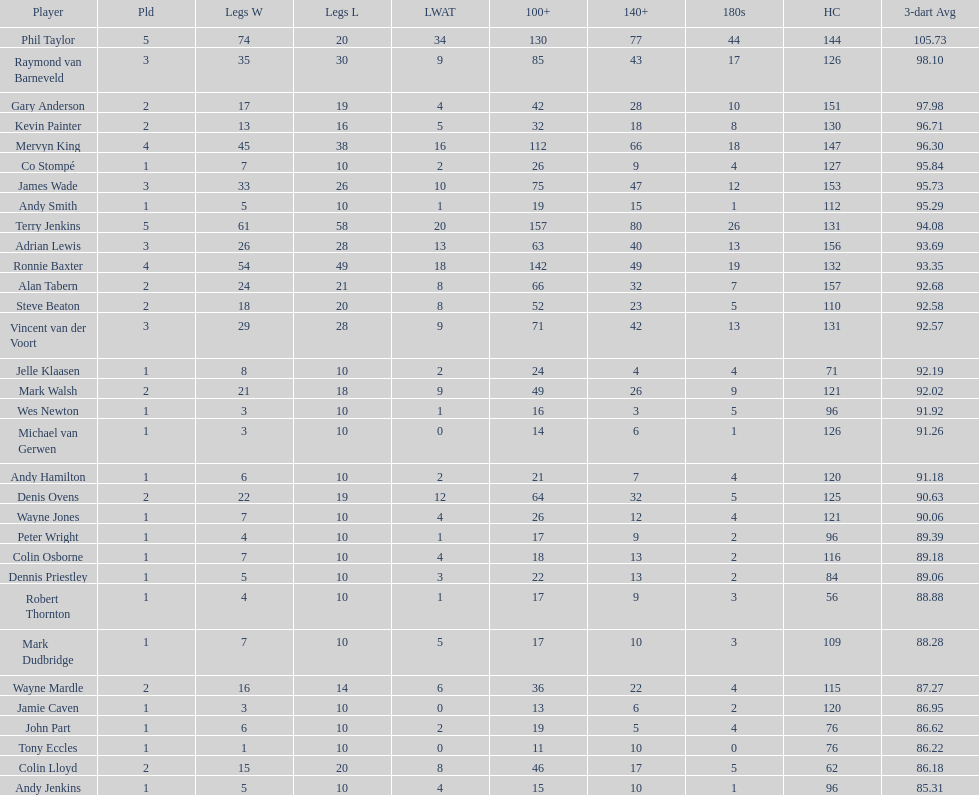How many participants in the 2009 world matchplay secured a minimum of 30 legs? 6. Can you give me this table as a dict? {'header': ['Player', 'Pld', 'Legs W', 'Legs L', 'LWAT', '100+', '140+', '180s', 'HC', '3-dart Avg'], 'rows': [['Phil Taylor', '5', '74', '20', '34', '130', '77', '44', '144', '105.73'], ['Raymond van Barneveld', '3', '35', '30', '9', '85', '43', '17', '126', '98.10'], ['Gary Anderson', '2', '17', '19', '4', '42', '28', '10', '151', '97.98'], ['Kevin Painter', '2', '13', '16', '5', '32', '18', '8', '130', '96.71'], ['Mervyn King', '4', '45', '38', '16', '112', '66', '18', '147', '96.30'], ['Co Stompé', '1', '7', '10', '2', '26', '9', '4', '127', '95.84'], ['James Wade', '3', '33', '26', '10', '75', '47', '12', '153', '95.73'], ['Andy Smith', '1', '5', '10', '1', '19', '15', '1', '112', '95.29'], ['Terry Jenkins', '5', '61', '58', '20', '157', '80', '26', '131', '94.08'], ['Adrian Lewis', '3', '26', '28', '13', '63', '40', '13', '156', '93.69'], ['Ronnie Baxter', '4', '54', '49', '18', '142', '49', '19', '132', '93.35'], ['Alan Tabern', '2', '24', '21', '8', '66', '32', '7', '157', '92.68'], ['Steve Beaton', '2', '18', '20', '8', '52', '23', '5', '110', '92.58'], ['Vincent van der Voort', '3', '29', '28', '9', '71', '42', '13', '131', '92.57'], ['Jelle Klaasen', '1', '8', '10', '2', '24', '4', '4', '71', '92.19'], ['Mark Walsh', '2', '21', '18', '9', '49', '26', '9', '121', '92.02'], ['Wes Newton', '1', '3', '10', '1', '16', '3', '5', '96', '91.92'], ['Michael van Gerwen', '1', '3', '10', '0', '14', '6', '1', '126', '91.26'], ['Andy Hamilton', '1', '6', '10', '2', '21', '7', '4', '120', '91.18'], ['Denis Ovens', '2', '22', '19', '12', '64', '32', '5', '125', '90.63'], ['Wayne Jones', '1', '7', '10', '4', '26', '12', '4', '121', '90.06'], ['Peter Wright', '1', '4', '10', '1', '17', '9', '2', '96', '89.39'], ['Colin Osborne', '1', '7', '10', '4', '18', '13', '2', '116', '89.18'], ['Dennis Priestley', '1', '5', '10', '3', '22', '13', '2', '84', '89.06'], ['Robert Thornton', '1', '4', '10', '1', '17', '9', '3', '56', '88.88'], ['Mark Dudbridge', '1', '7', '10', '5', '17', '10', '3', '109', '88.28'], ['Wayne Mardle', '2', '16', '14', '6', '36', '22', '4', '115', '87.27'], ['Jamie Caven', '1', '3', '10', '0', '13', '6', '2', '120', '86.95'], ['John Part', '1', '6', '10', '2', '19', '5', '4', '76', '86.62'], ['Tony Eccles', '1', '1', '10', '0', '11', '10', '0', '76', '86.22'], ['Colin Lloyd', '2', '15', '20', '8', '46', '17', '5', '62', '86.18'], ['Andy Jenkins', '1', '5', '10', '4', '15', '10', '1', '96', '85.31']]} 